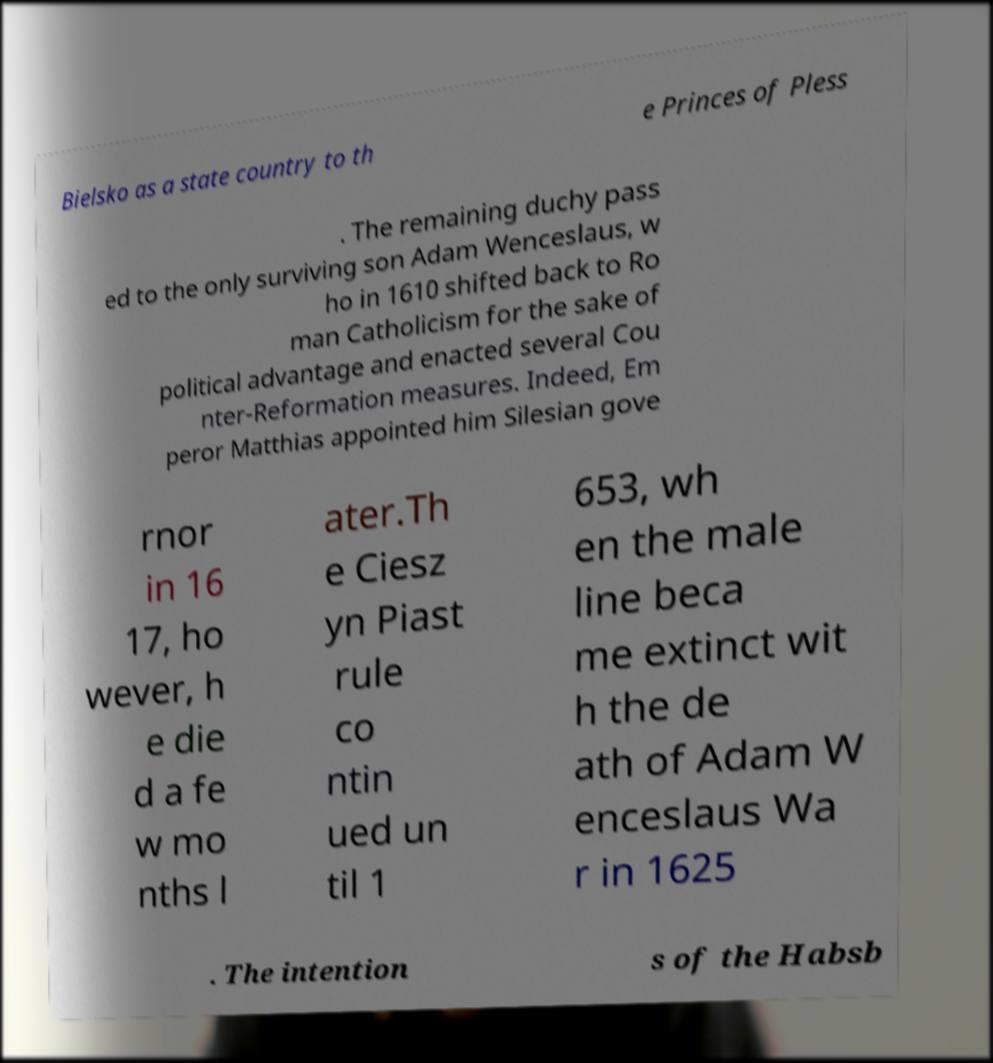Could you extract and type out the text from this image? Bielsko as a state country to th e Princes of Pless . The remaining duchy pass ed to the only surviving son Adam Wenceslaus, w ho in 1610 shifted back to Ro man Catholicism for the sake of political advantage and enacted several Cou nter-Reformation measures. Indeed, Em peror Matthias appointed him Silesian gove rnor in 16 17, ho wever, h e die d a fe w mo nths l ater.Th e Ciesz yn Piast rule co ntin ued un til 1 653, wh en the male line beca me extinct wit h the de ath of Adam W enceslaus Wa r in 1625 . The intention s of the Habsb 